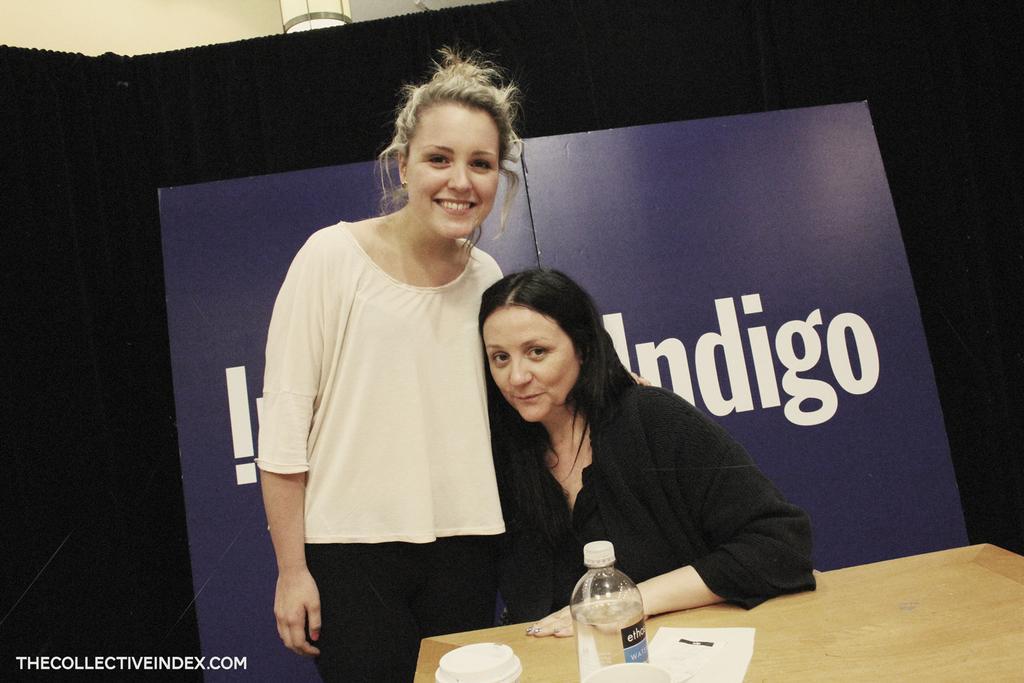Can you describe this image briefly? In this image we can see two persons. There are few objects placed on the table. There is an advertising board behind the ladies. There is a lamp at the top most of the image and some text written at the bottom most of the image. 